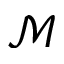Convert formula to latex. <formula><loc_0><loc_0><loc_500><loc_500>\ m a t h s c r { M }</formula> 